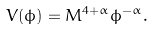Convert formula to latex. <formula><loc_0><loc_0><loc_500><loc_500>V ( \phi ) = M ^ { 4 + \alpha } \phi ^ { - \alpha } .</formula> 